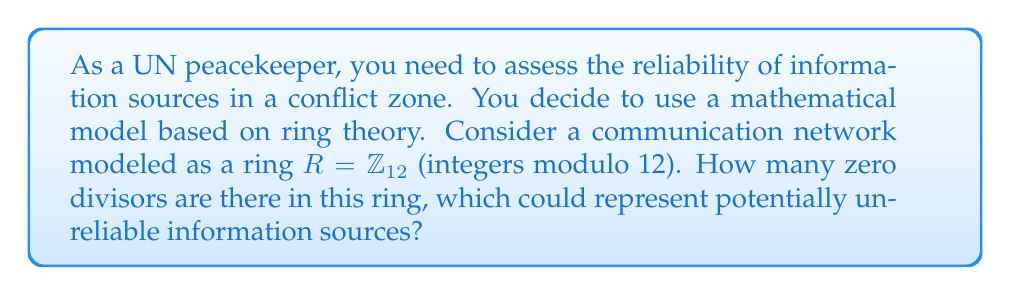Give your solution to this math problem. To solve this problem, we need to follow these steps:

1) First, recall that in a ring $R$, an element $a$ is a zero divisor if there exists a non-zero element $b$ in $R$ such that $ab = 0$.

2) In $\mathbb{Z}_{12}$, we need to find all elements $a$ such that there exists a non-zero $b$ where $ab \equiv 0 \pmod{12}$.

3) Let's check each element:

   - 0 is not considered a zero divisor by definition.
   - 1 is not a zero divisor as it's the multiplicative identity.
   - 2: $2 \cdot 6 \equiv 0 \pmod{12}$, so 2 is a zero divisor.
   - 3: $3 \cdot 4 \equiv 0 \pmod{12}$, so 3 is a zero divisor.
   - 4: $4 \cdot 3 \equiv 0 \pmod{12}$, so 4 is a zero divisor.
   - 5 is not a zero divisor as it has no non-zero multiple that's divisible by 12.
   - 6: $6 \cdot 2 \equiv 0 \pmod{12}$, so 6 is a zero divisor.
   - 7 is not a zero divisor as it has no non-zero multiple that's divisible by 12.
   - 8: $8 \cdot 3 \equiv 0 \pmod{12}$, so 8 is a zero divisor.
   - 9: $9 \cdot 4 \equiv 0 \pmod{12}$, so 9 is a zero divisor.
   - 10: $10 \cdot 6 \equiv 0 \pmod{12}$, so 10 is a zero divisor.
   - 11 is not a zero divisor as it has no non-zero multiple that's divisible by 12.

4) Counting the zero divisors: 2, 3, 4, 6, 8, 9, 10.

Therefore, there are 7 zero divisors in $\mathbb{Z}_{12}$.
Answer: There are 7 zero divisors in the ring $\mathbb{Z}_{12}$. 